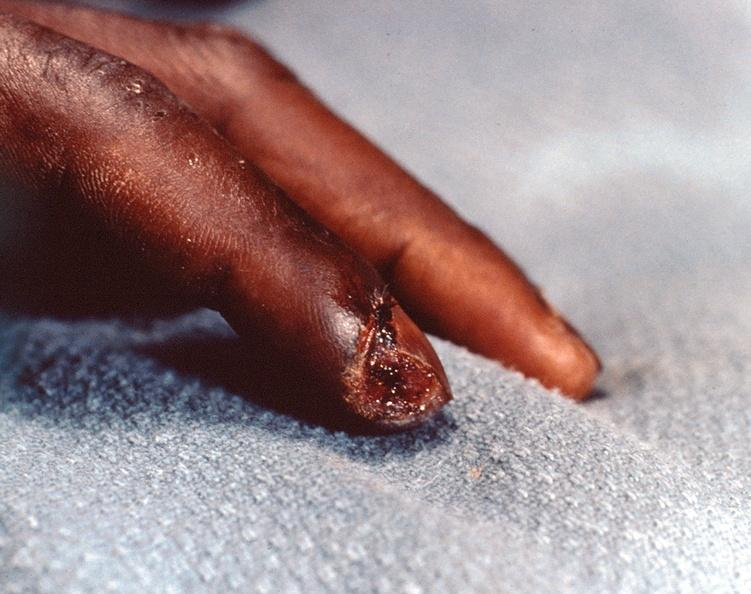what does this image show?
Answer the question using a single word or phrase. Necrosis of distal finger in a patient with panniculitis and fascitis 